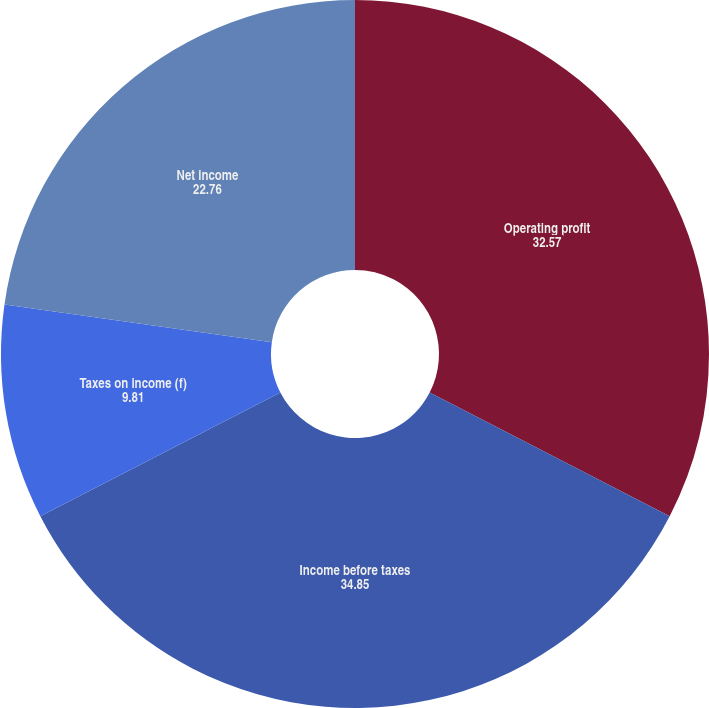<chart> <loc_0><loc_0><loc_500><loc_500><pie_chart><fcel>Operating profit<fcel>Income before taxes<fcel>Taxes on income (f)<fcel>Net income<nl><fcel>32.57%<fcel>34.85%<fcel>9.81%<fcel>22.76%<nl></chart> 